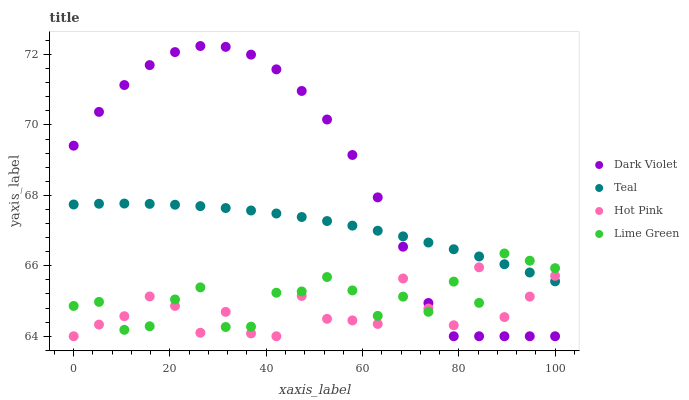Does Hot Pink have the minimum area under the curve?
Answer yes or no. Yes. Does Dark Violet have the maximum area under the curve?
Answer yes or no. Yes. Does Lime Green have the minimum area under the curve?
Answer yes or no. No. Does Lime Green have the maximum area under the curve?
Answer yes or no. No. Is Teal the smoothest?
Answer yes or no. Yes. Is Hot Pink the roughest?
Answer yes or no. Yes. Is Lime Green the smoothest?
Answer yes or no. No. Is Lime Green the roughest?
Answer yes or no. No. Does Hot Pink have the lowest value?
Answer yes or no. Yes. Does Lime Green have the lowest value?
Answer yes or no. No. Does Dark Violet have the highest value?
Answer yes or no. Yes. Does Lime Green have the highest value?
Answer yes or no. No. Does Dark Violet intersect Lime Green?
Answer yes or no. Yes. Is Dark Violet less than Lime Green?
Answer yes or no. No. Is Dark Violet greater than Lime Green?
Answer yes or no. No. 